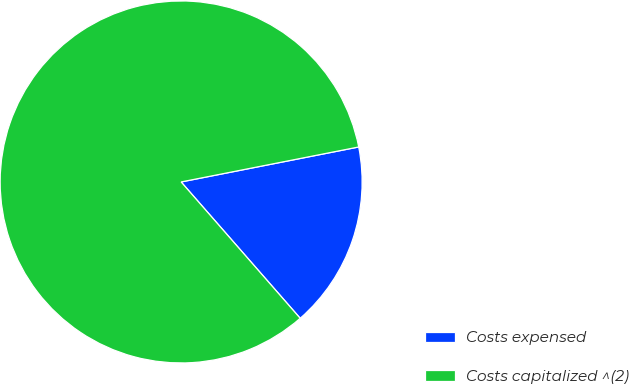<chart> <loc_0><loc_0><loc_500><loc_500><pie_chart><fcel>Costs expensed<fcel>Costs capitalized ^(2)<nl><fcel>16.67%<fcel>83.33%<nl></chart> 